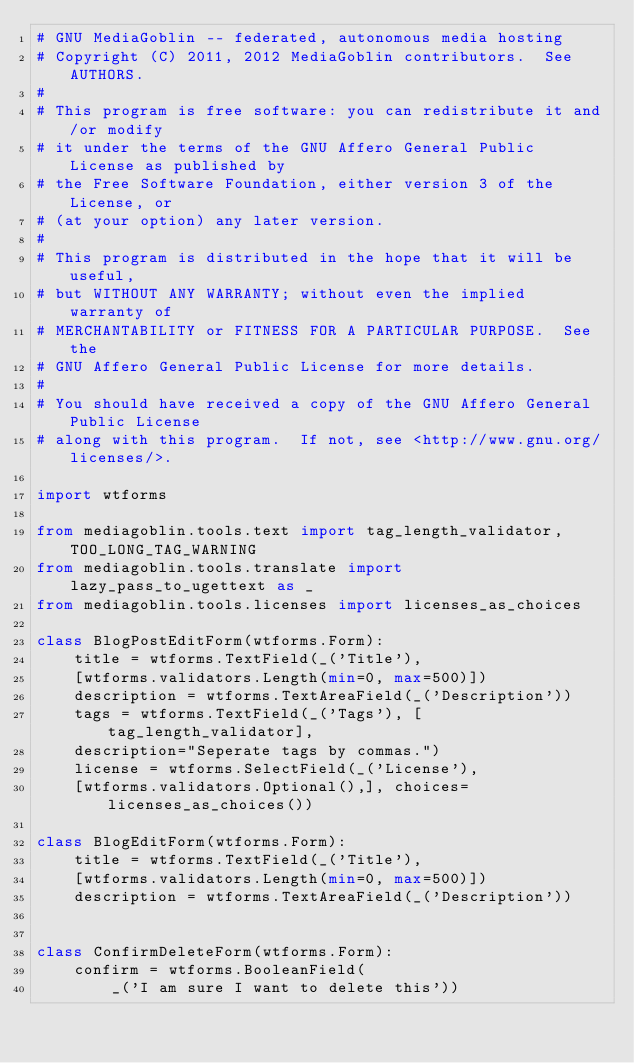Convert code to text. <code><loc_0><loc_0><loc_500><loc_500><_Python_># GNU MediaGoblin -- federated, autonomous media hosting
# Copyright (C) 2011, 2012 MediaGoblin contributors.  See AUTHORS.
#
# This program is free software: you can redistribute it and/or modify
# it under the terms of the GNU Affero General Public License as published by
# the Free Software Foundation, either version 3 of the License, or
# (at your option) any later version.
#
# This program is distributed in the hope that it will be useful,
# but WITHOUT ANY WARRANTY; without even the implied warranty of
# MERCHANTABILITY or FITNESS FOR A PARTICULAR PURPOSE.  See the
# GNU Affero General Public License for more details.
#
# You should have received a copy of the GNU Affero General Public License
# along with this program.  If not, see <http://www.gnu.org/licenses/>.

import wtforms

from mediagoblin.tools.text import tag_length_validator, TOO_LONG_TAG_WARNING
from mediagoblin.tools.translate import lazy_pass_to_ugettext as _
from mediagoblin.tools.licenses import licenses_as_choices

class BlogPostEditForm(wtforms.Form):
    title = wtforms.TextField(_('Title'),
		[wtforms.validators.Length(min=0, max=500)])
    description = wtforms.TextAreaField(_('Description'))
    tags = wtforms.TextField(_('Tags'), [tag_length_validator], 
		description="Seperate tags by commas.")
    license = wtforms.SelectField(_('License'), 
		[wtforms.validators.Optional(),], choices=licenses_as_choices())

class BlogEditForm(wtforms.Form):
    title = wtforms.TextField(_('Title'),
		[wtforms.validators.Length(min=0, max=500)])
    description = wtforms.TextAreaField(_('Description'))
    

class ConfirmDeleteForm(wtforms.Form):
    confirm = wtforms.BooleanField(
        _('I am sure I want to delete this'))
    

    
    
    
    
</code> 